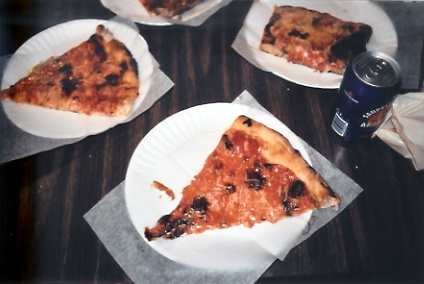Describe the objects in this image and their specific colors. I can see dining table in black and gray tones, pizza in black, salmon, and brown tones, pizza in black, brown, maroon, and salmon tones, and pizza in black, brown, and maroon tones in this image. 